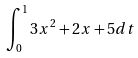<formula> <loc_0><loc_0><loc_500><loc_500>\int _ { 0 } ^ { 1 } 3 x ^ { 2 } + 2 x + 5 d t</formula> 